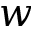<formula> <loc_0><loc_0><loc_500><loc_500>w</formula> 